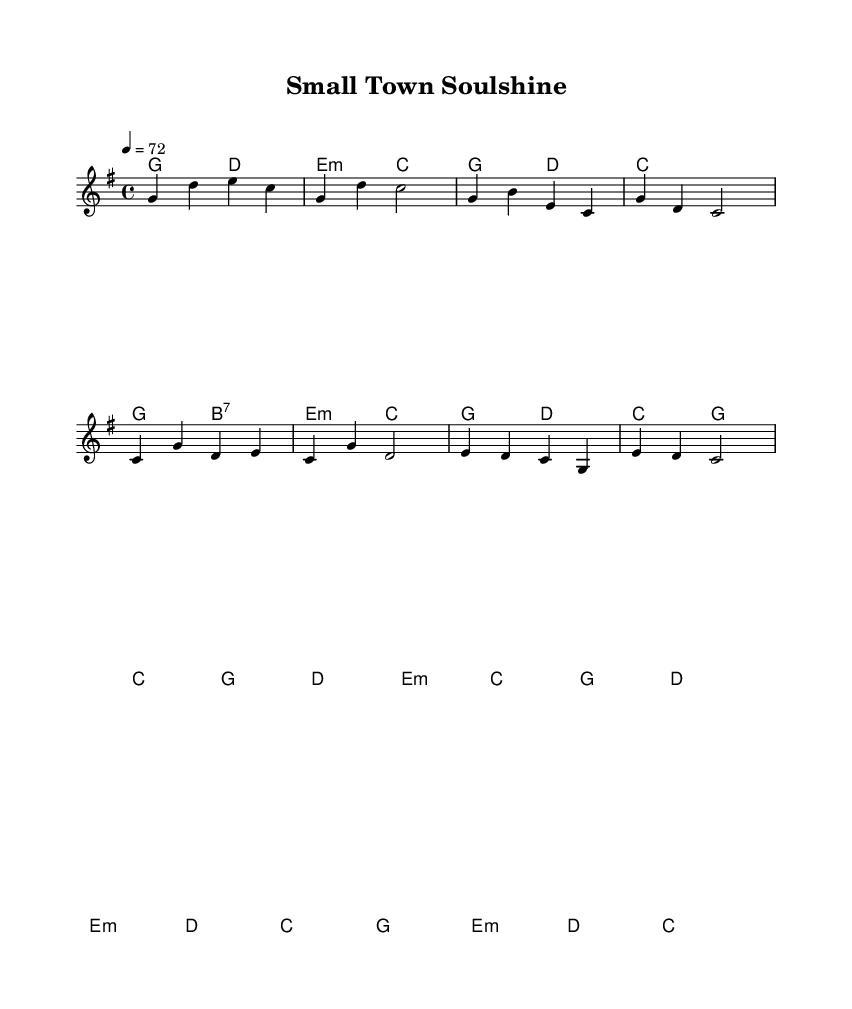What is the key signature of this music? The key signature is G major, which has one sharp (F#). This information is indicated at the beginning of the staff in the key signature section.
Answer: G major What is the time signature of the piece? The time signature is 4/4, which means there are four beats in each measure and the quarter note gets one beat. This is shown at the beginning of the music in the time signature section.
Answer: 4/4 What is the tempo marking for this piece? The tempo marking is 4 = 72, which indicates that there are 72 quarter note beats per minute. The tempo marking appears at the beginning of the score as part of the global settings.
Answer: 72 How many measures does the intro contain? The intro contains 4 measures, as indicated by the notation visually grouped in the music. Each measure is separated by a vertical line and can be counted easily.
Answer: 4 What type of chords are used in the harmonies? The harmonies include major and minor chords, specifically a mixture of major chords such as G and C, and minor chords such as E minor. The chord progression is outlined in the chord mode section and helps to define the piece's harmony.
Answer: Major and minor How does the chorus relate to the verse in terms of melody? The chorus contains a different melodic pattern from the verse, shifting to a broader range of notes. This contrast is typical in soul music, where an engaging and emotionally resonant chorus follows the narrative verse. You can see the melodic notes in the two sections to compare the differences directly.
Answer: Different melodic pattern What is the role of the bridge in this piece? The bridge provides a contrast to both the verse and chorus, often serving to heighten emotional intensity or introduce new themes. In this sheet music, the bridge is indicated as a separate section, and its harmonic and melodic changes are notably distinct from both the verse and chorus.
Answer: Contrast and intensity 